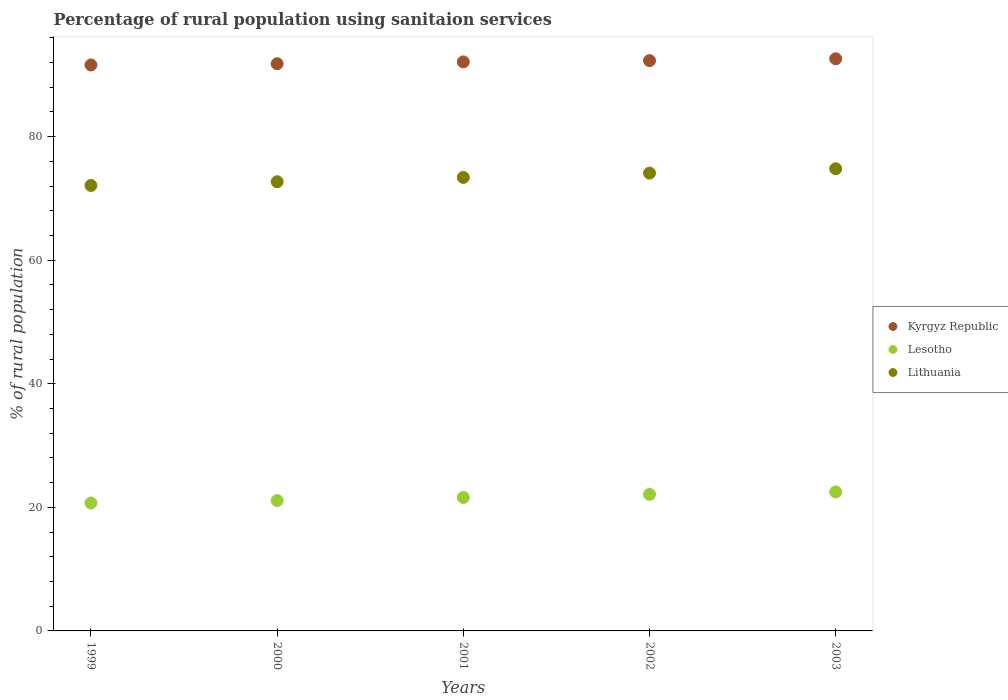How many different coloured dotlines are there?
Your response must be concise. 3. Is the number of dotlines equal to the number of legend labels?
Your response must be concise. Yes. What is the percentage of rural population using sanitaion services in Kyrgyz Republic in 2002?
Offer a very short reply. 92.3. Across all years, what is the maximum percentage of rural population using sanitaion services in Kyrgyz Republic?
Provide a succinct answer. 92.6. Across all years, what is the minimum percentage of rural population using sanitaion services in Lesotho?
Offer a terse response. 20.7. What is the total percentage of rural population using sanitaion services in Kyrgyz Republic in the graph?
Ensure brevity in your answer.  460.4. What is the difference between the percentage of rural population using sanitaion services in Kyrgyz Republic in 2000 and that in 2003?
Your answer should be very brief. -0.8. What is the difference between the percentage of rural population using sanitaion services in Kyrgyz Republic in 2003 and the percentage of rural population using sanitaion services in Lesotho in 2000?
Provide a short and direct response. 71.5. What is the average percentage of rural population using sanitaion services in Lesotho per year?
Give a very brief answer. 21.6. In the year 2002, what is the difference between the percentage of rural population using sanitaion services in Kyrgyz Republic and percentage of rural population using sanitaion services in Lithuania?
Provide a succinct answer. 18.2. In how many years, is the percentage of rural population using sanitaion services in Kyrgyz Republic greater than 56 %?
Give a very brief answer. 5. What is the ratio of the percentage of rural population using sanitaion services in Lithuania in 1999 to that in 2001?
Give a very brief answer. 0.98. Is the percentage of rural population using sanitaion services in Kyrgyz Republic in 2000 less than that in 2003?
Provide a succinct answer. Yes. Is the difference between the percentage of rural population using sanitaion services in Kyrgyz Republic in 1999 and 2003 greater than the difference between the percentage of rural population using sanitaion services in Lithuania in 1999 and 2003?
Make the answer very short. Yes. What is the difference between the highest and the second highest percentage of rural population using sanitaion services in Kyrgyz Republic?
Provide a short and direct response. 0.3. Is the sum of the percentage of rural population using sanitaion services in Kyrgyz Republic in 2001 and 2003 greater than the maximum percentage of rural population using sanitaion services in Lithuania across all years?
Your response must be concise. Yes. Is the percentage of rural population using sanitaion services in Kyrgyz Republic strictly greater than the percentage of rural population using sanitaion services in Lithuania over the years?
Your answer should be very brief. Yes. Does the graph contain any zero values?
Your response must be concise. No. Does the graph contain grids?
Make the answer very short. No. Where does the legend appear in the graph?
Offer a very short reply. Center right. How are the legend labels stacked?
Offer a terse response. Vertical. What is the title of the graph?
Give a very brief answer. Percentage of rural population using sanitaion services. Does "Congo (Republic)" appear as one of the legend labels in the graph?
Make the answer very short. No. What is the label or title of the Y-axis?
Give a very brief answer. % of rural population. What is the % of rural population of Kyrgyz Republic in 1999?
Provide a succinct answer. 91.6. What is the % of rural population of Lesotho in 1999?
Offer a terse response. 20.7. What is the % of rural population of Lithuania in 1999?
Ensure brevity in your answer.  72.1. What is the % of rural population of Kyrgyz Republic in 2000?
Offer a terse response. 91.8. What is the % of rural population of Lesotho in 2000?
Ensure brevity in your answer.  21.1. What is the % of rural population of Lithuania in 2000?
Offer a very short reply. 72.7. What is the % of rural population of Kyrgyz Republic in 2001?
Your answer should be compact. 92.1. What is the % of rural population of Lesotho in 2001?
Make the answer very short. 21.6. What is the % of rural population of Lithuania in 2001?
Your response must be concise. 73.4. What is the % of rural population in Kyrgyz Republic in 2002?
Offer a terse response. 92.3. What is the % of rural population of Lesotho in 2002?
Keep it short and to the point. 22.1. What is the % of rural population of Lithuania in 2002?
Make the answer very short. 74.1. What is the % of rural population in Kyrgyz Republic in 2003?
Offer a terse response. 92.6. What is the % of rural population of Lithuania in 2003?
Your answer should be very brief. 74.8. Across all years, what is the maximum % of rural population of Kyrgyz Republic?
Offer a very short reply. 92.6. Across all years, what is the maximum % of rural population in Lithuania?
Provide a short and direct response. 74.8. Across all years, what is the minimum % of rural population in Kyrgyz Republic?
Give a very brief answer. 91.6. Across all years, what is the minimum % of rural population in Lesotho?
Give a very brief answer. 20.7. Across all years, what is the minimum % of rural population of Lithuania?
Ensure brevity in your answer.  72.1. What is the total % of rural population in Kyrgyz Republic in the graph?
Provide a short and direct response. 460.4. What is the total % of rural population in Lesotho in the graph?
Make the answer very short. 108. What is the total % of rural population of Lithuania in the graph?
Keep it short and to the point. 367.1. What is the difference between the % of rural population of Lesotho in 1999 and that in 2000?
Keep it short and to the point. -0.4. What is the difference between the % of rural population in Lesotho in 1999 and that in 2001?
Offer a terse response. -0.9. What is the difference between the % of rural population in Lesotho in 1999 and that in 2002?
Offer a terse response. -1.4. What is the difference between the % of rural population of Kyrgyz Republic in 2000 and that in 2001?
Give a very brief answer. -0.3. What is the difference between the % of rural population in Kyrgyz Republic in 2000 and that in 2002?
Your answer should be compact. -0.5. What is the difference between the % of rural population in Lithuania in 2000 and that in 2002?
Your answer should be very brief. -1.4. What is the difference between the % of rural population of Kyrgyz Republic in 2001 and that in 2003?
Your answer should be compact. -0.5. What is the difference between the % of rural population in Lesotho in 2002 and that in 2003?
Offer a very short reply. -0.4. What is the difference between the % of rural population in Kyrgyz Republic in 1999 and the % of rural population in Lesotho in 2000?
Provide a succinct answer. 70.5. What is the difference between the % of rural population of Lesotho in 1999 and the % of rural population of Lithuania in 2000?
Offer a terse response. -52. What is the difference between the % of rural population in Kyrgyz Republic in 1999 and the % of rural population in Lesotho in 2001?
Give a very brief answer. 70. What is the difference between the % of rural population of Kyrgyz Republic in 1999 and the % of rural population of Lithuania in 2001?
Your response must be concise. 18.2. What is the difference between the % of rural population of Lesotho in 1999 and the % of rural population of Lithuania in 2001?
Keep it short and to the point. -52.7. What is the difference between the % of rural population in Kyrgyz Republic in 1999 and the % of rural population in Lesotho in 2002?
Offer a very short reply. 69.5. What is the difference between the % of rural population in Kyrgyz Republic in 1999 and the % of rural population in Lithuania in 2002?
Your answer should be very brief. 17.5. What is the difference between the % of rural population of Lesotho in 1999 and the % of rural population of Lithuania in 2002?
Your answer should be compact. -53.4. What is the difference between the % of rural population of Kyrgyz Republic in 1999 and the % of rural population of Lesotho in 2003?
Provide a short and direct response. 69.1. What is the difference between the % of rural population in Lesotho in 1999 and the % of rural population in Lithuania in 2003?
Provide a succinct answer. -54.1. What is the difference between the % of rural population of Kyrgyz Republic in 2000 and the % of rural population of Lesotho in 2001?
Your response must be concise. 70.2. What is the difference between the % of rural population in Kyrgyz Republic in 2000 and the % of rural population in Lithuania in 2001?
Ensure brevity in your answer.  18.4. What is the difference between the % of rural population in Lesotho in 2000 and the % of rural population in Lithuania in 2001?
Your response must be concise. -52.3. What is the difference between the % of rural population of Kyrgyz Republic in 2000 and the % of rural population of Lesotho in 2002?
Ensure brevity in your answer.  69.7. What is the difference between the % of rural population of Kyrgyz Republic in 2000 and the % of rural population of Lithuania in 2002?
Give a very brief answer. 17.7. What is the difference between the % of rural population in Lesotho in 2000 and the % of rural population in Lithuania in 2002?
Your response must be concise. -53. What is the difference between the % of rural population in Kyrgyz Republic in 2000 and the % of rural population in Lesotho in 2003?
Provide a succinct answer. 69.3. What is the difference between the % of rural population in Lesotho in 2000 and the % of rural population in Lithuania in 2003?
Your answer should be compact. -53.7. What is the difference between the % of rural population in Kyrgyz Republic in 2001 and the % of rural population in Lesotho in 2002?
Ensure brevity in your answer.  70. What is the difference between the % of rural population of Kyrgyz Republic in 2001 and the % of rural population of Lithuania in 2002?
Provide a short and direct response. 18. What is the difference between the % of rural population of Lesotho in 2001 and the % of rural population of Lithuania in 2002?
Provide a succinct answer. -52.5. What is the difference between the % of rural population of Kyrgyz Republic in 2001 and the % of rural population of Lesotho in 2003?
Your answer should be very brief. 69.6. What is the difference between the % of rural population of Lesotho in 2001 and the % of rural population of Lithuania in 2003?
Provide a short and direct response. -53.2. What is the difference between the % of rural population in Kyrgyz Republic in 2002 and the % of rural population in Lesotho in 2003?
Give a very brief answer. 69.8. What is the difference between the % of rural population of Lesotho in 2002 and the % of rural population of Lithuania in 2003?
Your answer should be compact. -52.7. What is the average % of rural population in Kyrgyz Republic per year?
Make the answer very short. 92.08. What is the average % of rural population in Lesotho per year?
Provide a succinct answer. 21.6. What is the average % of rural population of Lithuania per year?
Offer a terse response. 73.42. In the year 1999, what is the difference between the % of rural population in Kyrgyz Republic and % of rural population in Lesotho?
Give a very brief answer. 70.9. In the year 1999, what is the difference between the % of rural population in Kyrgyz Republic and % of rural population in Lithuania?
Keep it short and to the point. 19.5. In the year 1999, what is the difference between the % of rural population of Lesotho and % of rural population of Lithuania?
Your answer should be very brief. -51.4. In the year 2000, what is the difference between the % of rural population of Kyrgyz Republic and % of rural population of Lesotho?
Your response must be concise. 70.7. In the year 2000, what is the difference between the % of rural population in Lesotho and % of rural population in Lithuania?
Provide a short and direct response. -51.6. In the year 2001, what is the difference between the % of rural population of Kyrgyz Republic and % of rural population of Lesotho?
Ensure brevity in your answer.  70.5. In the year 2001, what is the difference between the % of rural population of Kyrgyz Republic and % of rural population of Lithuania?
Your answer should be very brief. 18.7. In the year 2001, what is the difference between the % of rural population in Lesotho and % of rural population in Lithuania?
Your answer should be compact. -51.8. In the year 2002, what is the difference between the % of rural population of Kyrgyz Republic and % of rural population of Lesotho?
Make the answer very short. 70.2. In the year 2002, what is the difference between the % of rural population in Lesotho and % of rural population in Lithuania?
Provide a short and direct response. -52. In the year 2003, what is the difference between the % of rural population in Kyrgyz Republic and % of rural population in Lesotho?
Provide a succinct answer. 70.1. In the year 2003, what is the difference between the % of rural population in Kyrgyz Republic and % of rural population in Lithuania?
Your response must be concise. 17.8. In the year 2003, what is the difference between the % of rural population of Lesotho and % of rural population of Lithuania?
Offer a very short reply. -52.3. What is the ratio of the % of rural population in Lithuania in 1999 to that in 2000?
Offer a very short reply. 0.99. What is the ratio of the % of rural population of Lithuania in 1999 to that in 2001?
Provide a succinct answer. 0.98. What is the ratio of the % of rural population of Kyrgyz Republic in 1999 to that in 2002?
Keep it short and to the point. 0.99. What is the ratio of the % of rural population of Lesotho in 1999 to that in 2002?
Make the answer very short. 0.94. What is the ratio of the % of rural population in Kyrgyz Republic in 1999 to that in 2003?
Provide a short and direct response. 0.99. What is the ratio of the % of rural population in Lithuania in 1999 to that in 2003?
Your answer should be compact. 0.96. What is the ratio of the % of rural population of Lesotho in 2000 to that in 2001?
Your answer should be compact. 0.98. What is the ratio of the % of rural population in Lesotho in 2000 to that in 2002?
Your answer should be compact. 0.95. What is the ratio of the % of rural population of Lithuania in 2000 to that in 2002?
Ensure brevity in your answer.  0.98. What is the ratio of the % of rural population in Kyrgyz Republic in 2000 to that in 2003?
Offer a terse response. 0.99. What is the ratio of the % of rural population of Lesotho in 2000 to that in 2003?
Keep it short and to the point. 0.94. What is the ratio of the % of rural population of Lithuania in 2000 to that in 2003?
Your answer should be very brief. 0.97. What is the ratio of the % of rural population in Kyrgyz Republic in 2001 to that in 2002?
Your answer should be compact. 1. What is the ratio of the % of rural population in Lesotho in 2001 to that in 2002?
Your response must be concise. 0.98. What is the ratio of the % of rural population in Lithuania in 2001 to that in 2002?
Make the answer very short. 0.99. What is the ratio of the % of rural population of Lesotho in 2001 to that in 2003?
Your answer should be very brief. 0.96. What is the ratio of the % of rural population of Lithuania in 2001 to that in 2003?
Make the answer very short. 0.98. What is the ratio of the % of rural population in Lesotho in 2002 to that in 2003?
Offer a very short reply. 0.98. What is the ratio of the % of rural population of Lithuania in 2002 to that in 2003?
Your answer should be very brief. 0.99. What is the difference between the highest and the lowest % of rural population of Kyrgyz Republic?
Your answer should be very brief. 1. What is the difference between the highest and the lowest % of rural population in Lithuania?
Give a very brief answer. 2.7. 